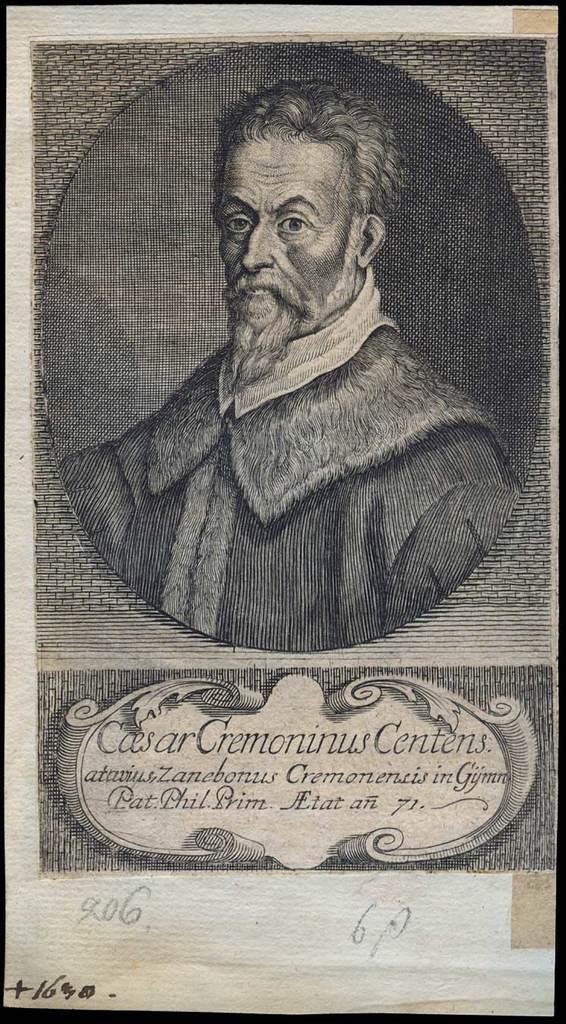Can you describe this image briefly? In this image there is a person on the poster, there is text written on the poster, there is number written on the poster. 